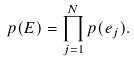<formula> <loc_0><loc_0><loc_500><loc_500>p ( E ) = \prod _ { j = 1 } ^ { N } p ( e _ { j } ) .</formula> 